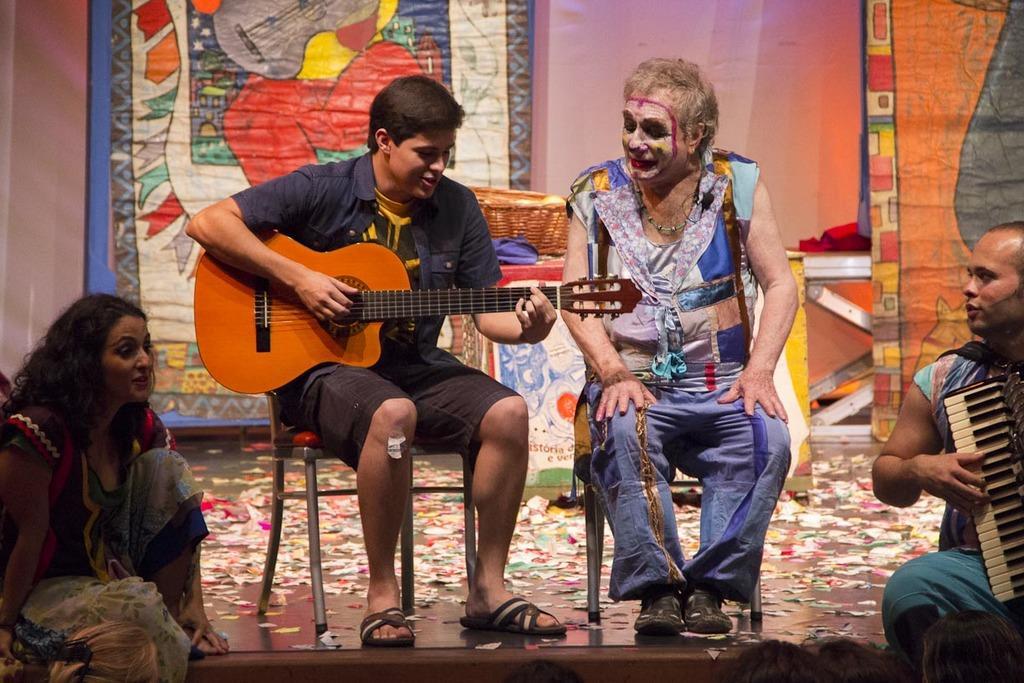Can you describe this image briefly? This picture is of inside. On the right corner there is a man sitting and playing a musical instrument. On the right there is a man sitting on the chair and smiling. On the left there is a man sitting on the chair and playing guitar. On the left corner there is a woman sitting. In the foreground we can see the group of persons in the background we can see the table on which a wooden basket is placed and there is a wall and curtain and we can see the table in the background. 